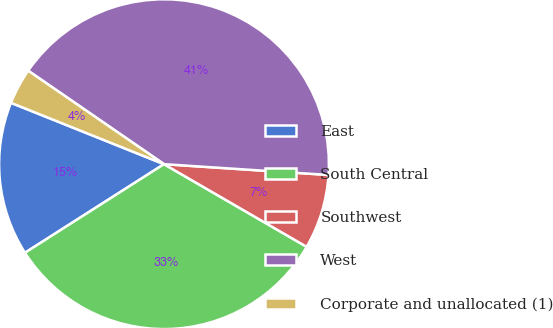Convert chart to OTSL. <chart><loc_0><loc_0><loc_500><loc_500><pie_chart><fcel>East<fcel>South Central<fcel>Southwest<fcel>West<fcel>Corporate and unallocated (1)<nl><fcel>15.1%<fcel>32.61%<fcel>7.31%<fcel>41.45%<fcel>3.52%<nl></chart> 